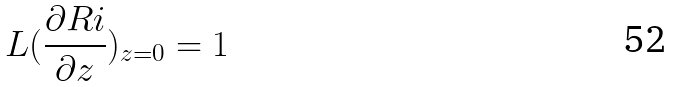Convert formula to latex. <formula><loc_0><loc_0><loc_500><loc_500>L ( \frac { \partial R i } { \partial z } ) _ { z = 0 } = 1</formula> 